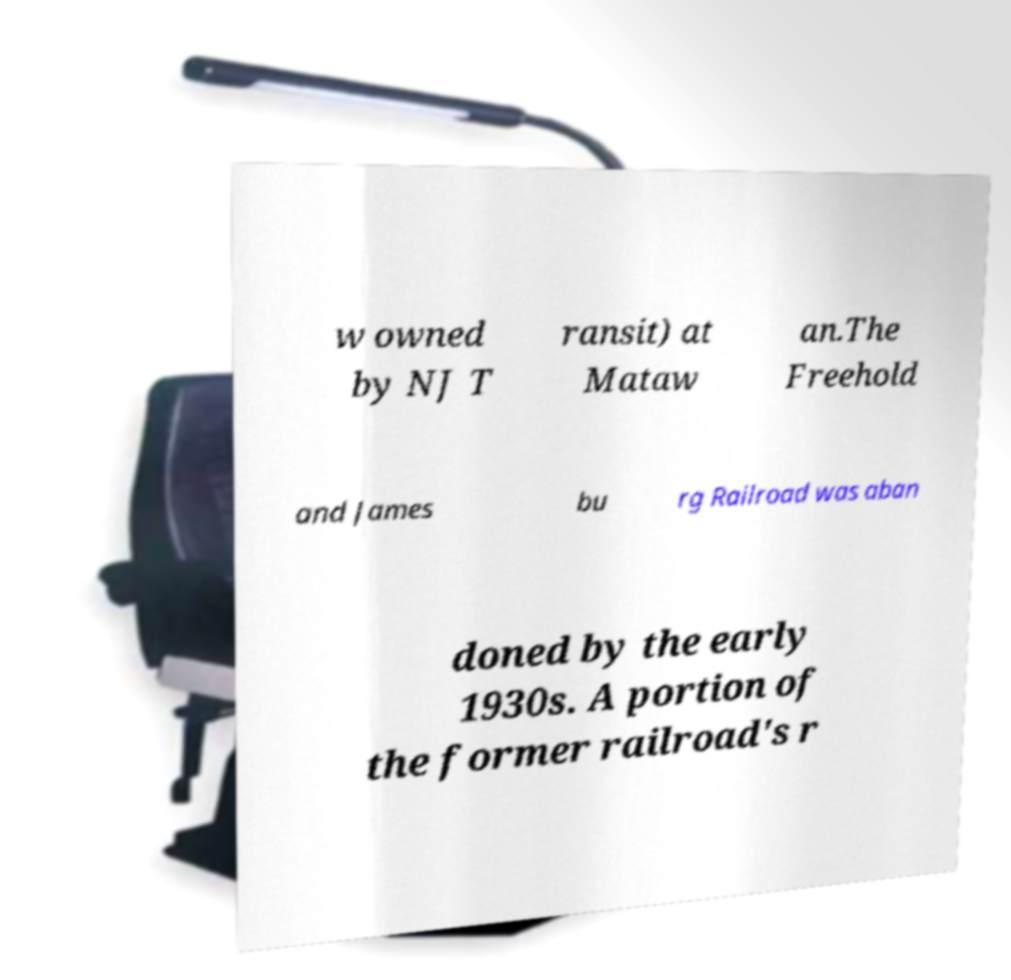Could you extract and type out the text from this image? w owned by NJ T ransit) at Mataw an.The Freehold and James bu rg Railroad was aban doned by the early 1930s. A portion of the former railroad's r 